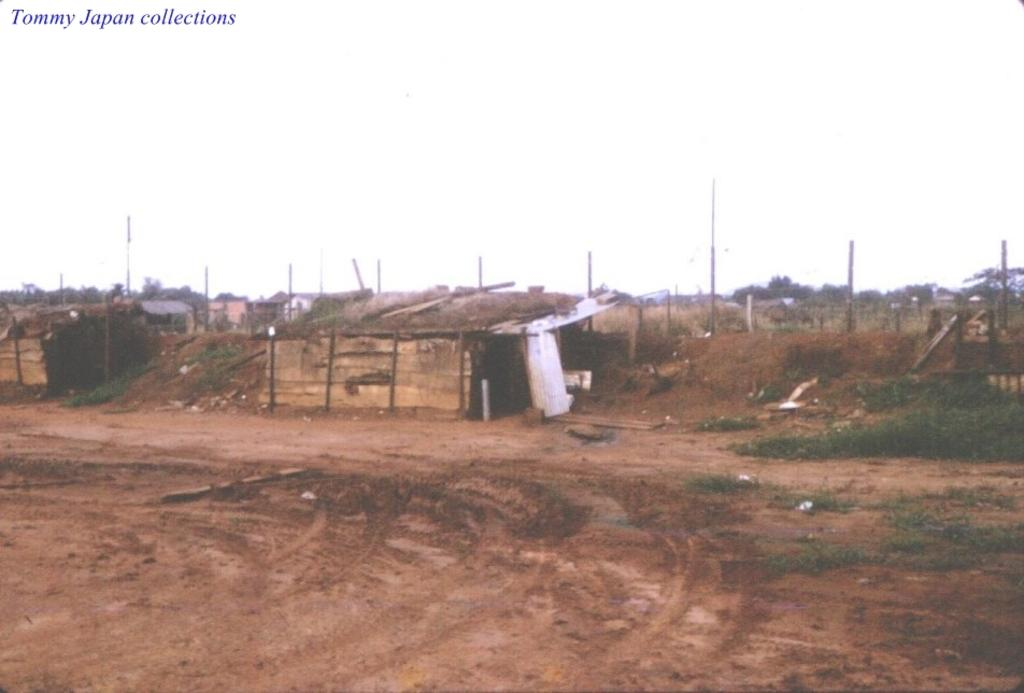What type of structures can be seen in the image? There are sheds in the image. What else can be seen in the image besides the sheds? There are poles and a fence visible in the image. What is the ground surface like in the image? The ground is visible in the image, and there is grass present. What type of vegetation is in the image? There are trees in the image. What part of the natural environment is visible in the image? The sky is visible in the image. Can you see a patch of squirrels climbing the trees in the image? There is no patch of squirrels climbing the trees in the image; only the sheds, poles, fence, grass, trees, and sky are present. 